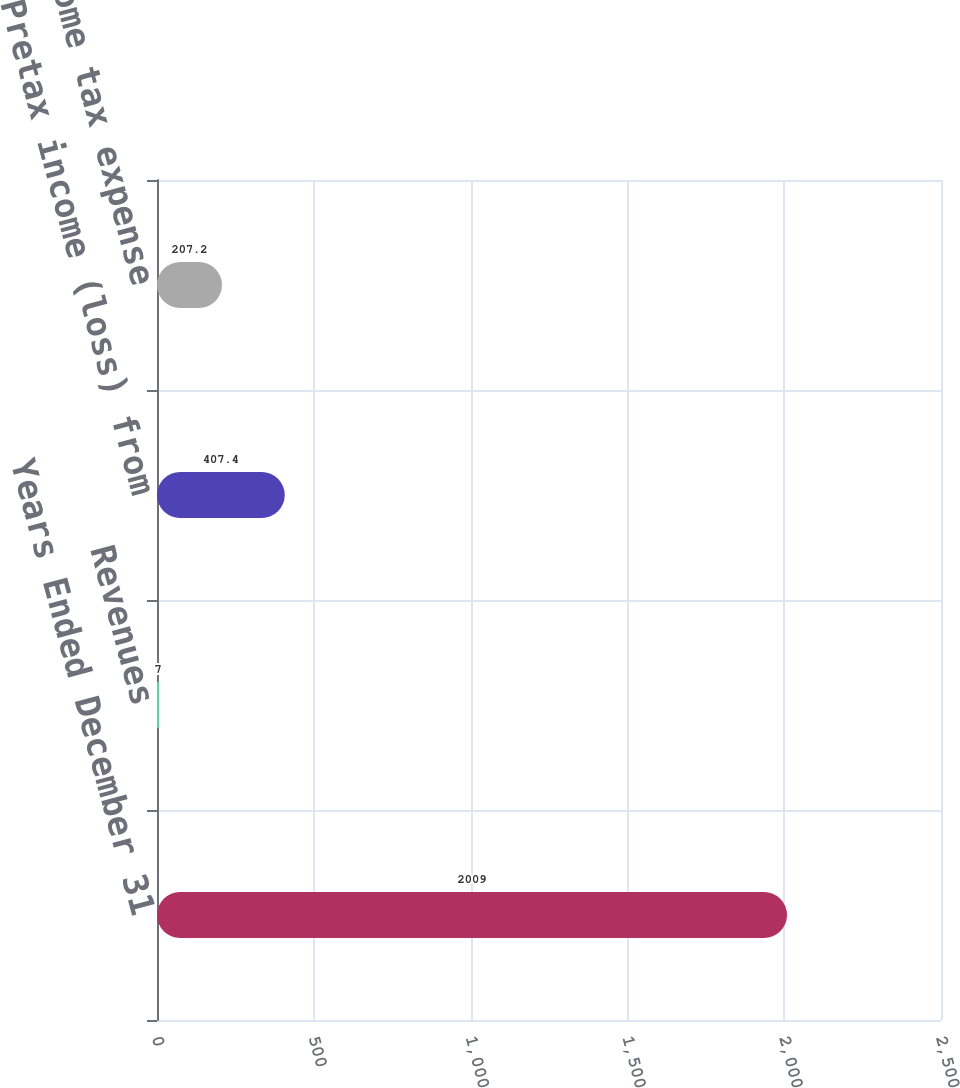<chart> <loc_0><loc_0><loc_500><loc_500><bar_chart><fcel>Years Ended December 31<fcel>Revenues<fcel>Pretax income (loss) from<fcel>Income tax expense<nl><fcel>2009<fcel>7<fcel>407.4<fcel>207.2<nl></chart> 